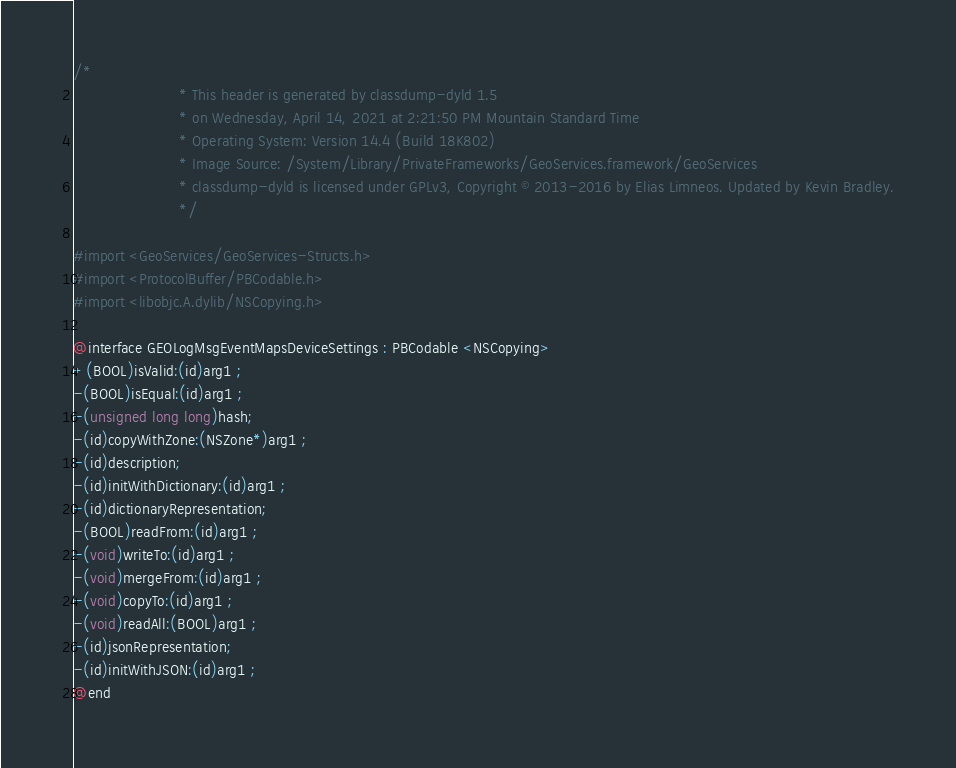<code> <loc_0><loc_0><loc_500><loc_500><_C_>/*
                       * This header is generated by classdump-dyld 1.5
                       * on Wednesday, April 14, 2021 at 2:21:50 PM Mountain Standard Time
                       * Operating System: Version 14.4 (Build 18K802)
                       * Image Source: /System/Library/PrivateFrameworks/GeoServices.framework/GeoServices
                       * classdump-dyld is licensed under GPLv3, Copyright © 2013-2016 by Elias Limneos. Updated by Kevin Bradley.
                       */

#import <GeoServices/GeoServices-Structs.h>
#import <ProtocolBuffer/PBCodable.h>
#import <libobjc.A.dylib/NSCopying.h>

@interface GEOLogMsgEventMapsDeviceSettings : PBCodable <NSCopying>
+(BOOL)isValid:(id)arg1 ;
-(BOOL)isEqual:(id)arg1 ;
-(unsigned long long)hash;
-(id)copyWithZone:(NSZone*)arg1 ;
-(id)description;
-(id)initWithDictionary:(id)arg1 ;
-(id)dictionaryRepresentation;
-(BOOL)readFrom:(id)arg1 ;
-(void)writeTo:(id)arg1 ;
-(void)mergeFrom:(id)arg1 ;
-(void)copyTo:(id)arg1 ;
-(void)readAll:(BOOL)arg1 ;
-(id)jsonRepresentation;
-(id)initWithJSON:(id)arg1 ;
@end

</code> 